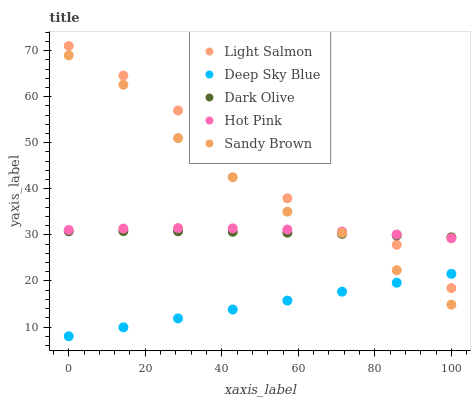Does Deep Sky Blue have the minimum area under the curve?
Answer yes or no. Yes. Does Light Salmon have the maximum area under the curve?
Answer yes or no. Yes. Does Dark Olive have the minimum area under the curve?
Answer yes or no. No. Does Dark Olive have the maximum area under the curve?
Answer yes or no. No. Is Deep Sky Blue the smoothest?
Answer yes or no. Yes. Is Light Salmon the roughest?
Answer yes or no. Yes. Is Dark Olive the smoothest?
Answer yes or no. No. Is Dark Olive the roughest?
Answer yes or no. No. Does Deep Sky Blue have the lowest value?
Answer yes or no. Yes. Does Sandy Brown have the lowest value?
Answer yes or no. No. Does Light Salmon have the highest value?
Answer yes or no. Yes. Does Dark Olive have the highest value?
Answer yes or no. No. Is Sandy Brown less than Light Salmon?
Answer yes or no. Yes. Is Dark Olive greater than Deep Sky Blue?
Answer yes or no. Yes. Does Sandy Brown intersect Deep Sky Blue?
Answer yes or no. Yes. Is Sandy Brown less than Deep Sky Blue?
Answer yes or no. No. Is Sandy Brown greater than Deep Sky Blue?
Answer yes or no. No. Does Sandy Brown intersect Light Salmon?
Answer yes or no. No. 